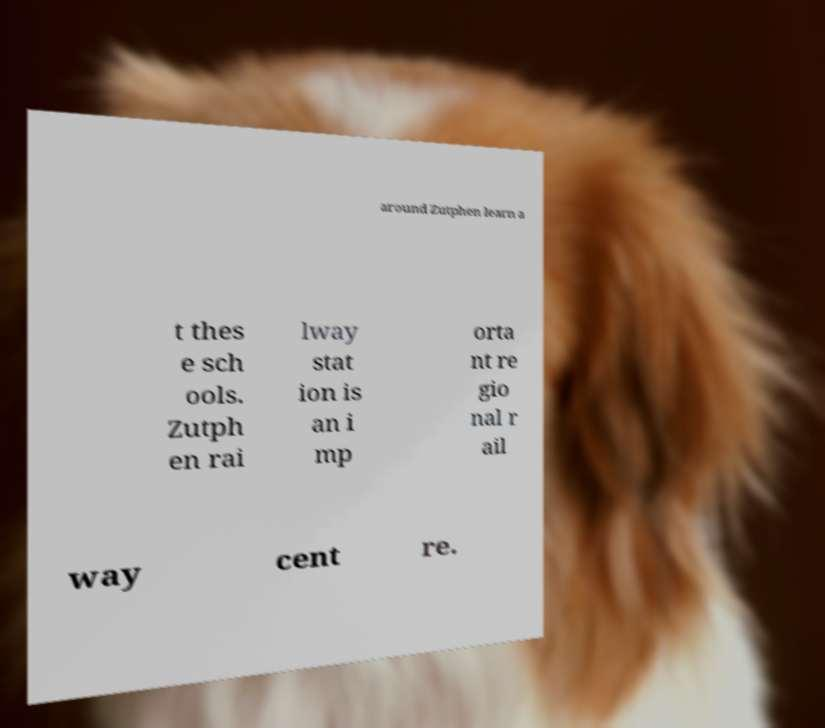Can you accurately transcribe the text from the provided image for me? around Zutphen learn a t thes e sch ools. Zutph en rai lway stat ion is an i mp orta nt re gio nal r ail way cent re. 